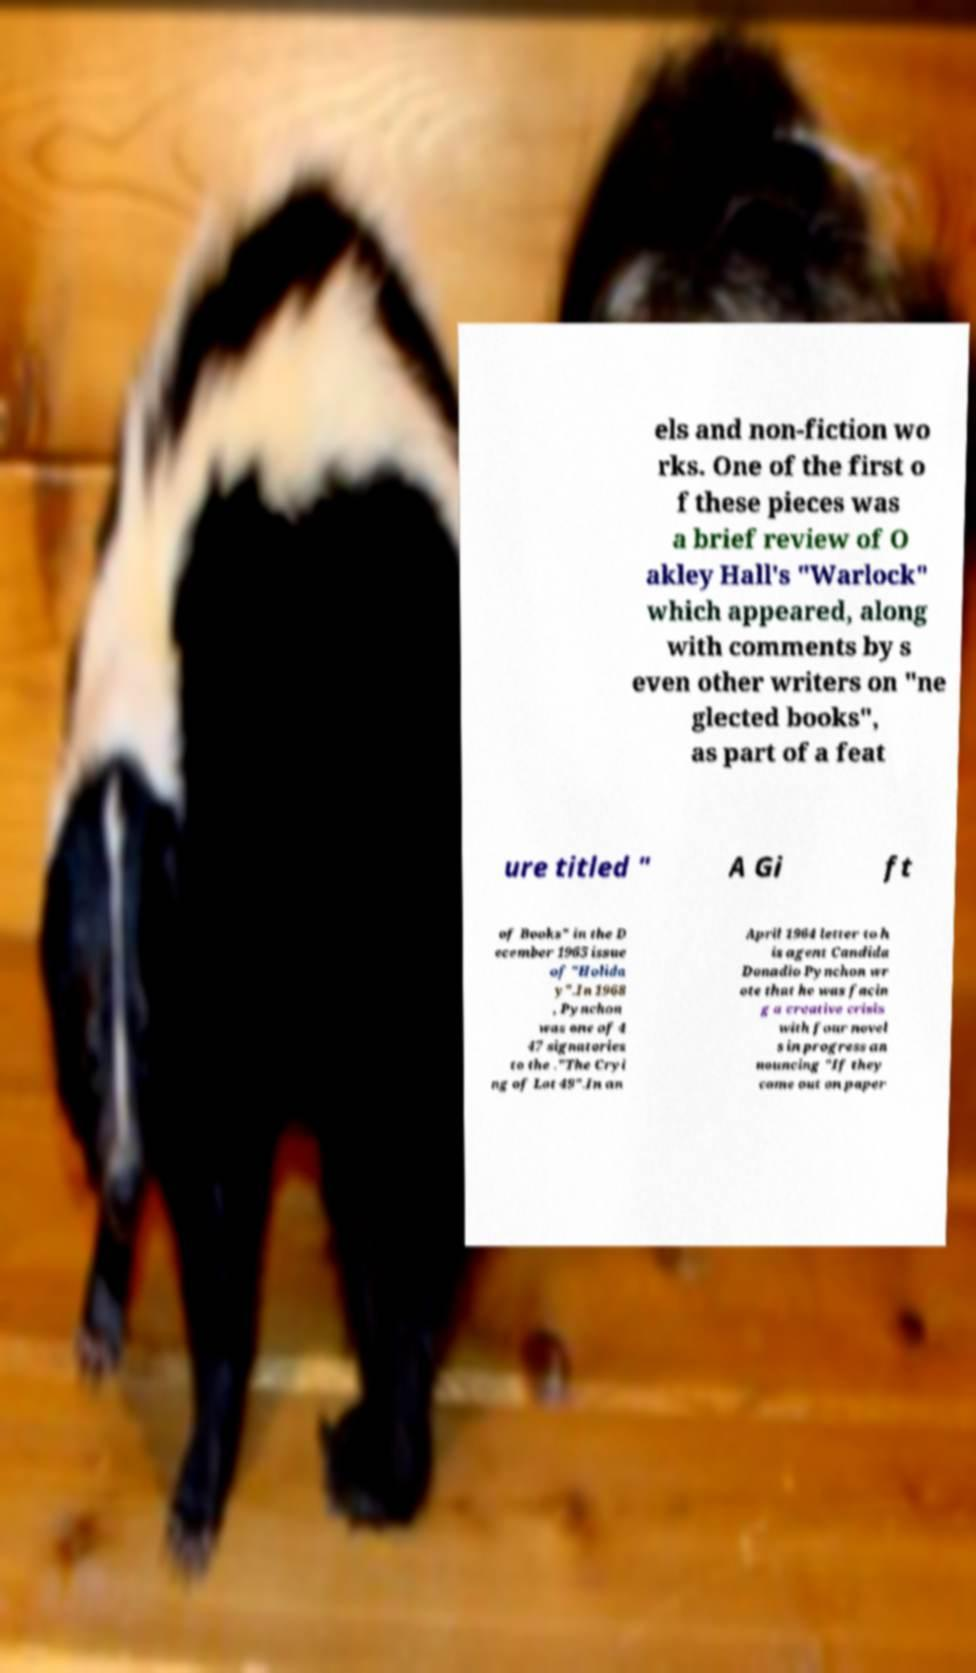Could you extract and type out the text from this image? els and non-fiction wo rks. One of the first o f these pieces was a brief review of O akley Hall's "Warlock" which appeared, along with comments by s even other writers on "ne glected books", as part of a feat ure titled " A Gi ft of Books" in the D ecember 1965 issue of "Holida y".In 1968 , Pynchon was one of 4 47 signatories to the ."The Cryi ng of Lot 49".In an April 1964 letter to h is agent Candida Donadio Pynchon wr ote that he was facin g a creative crisis with four novel s in progress an nouncing "If they come out on paper 